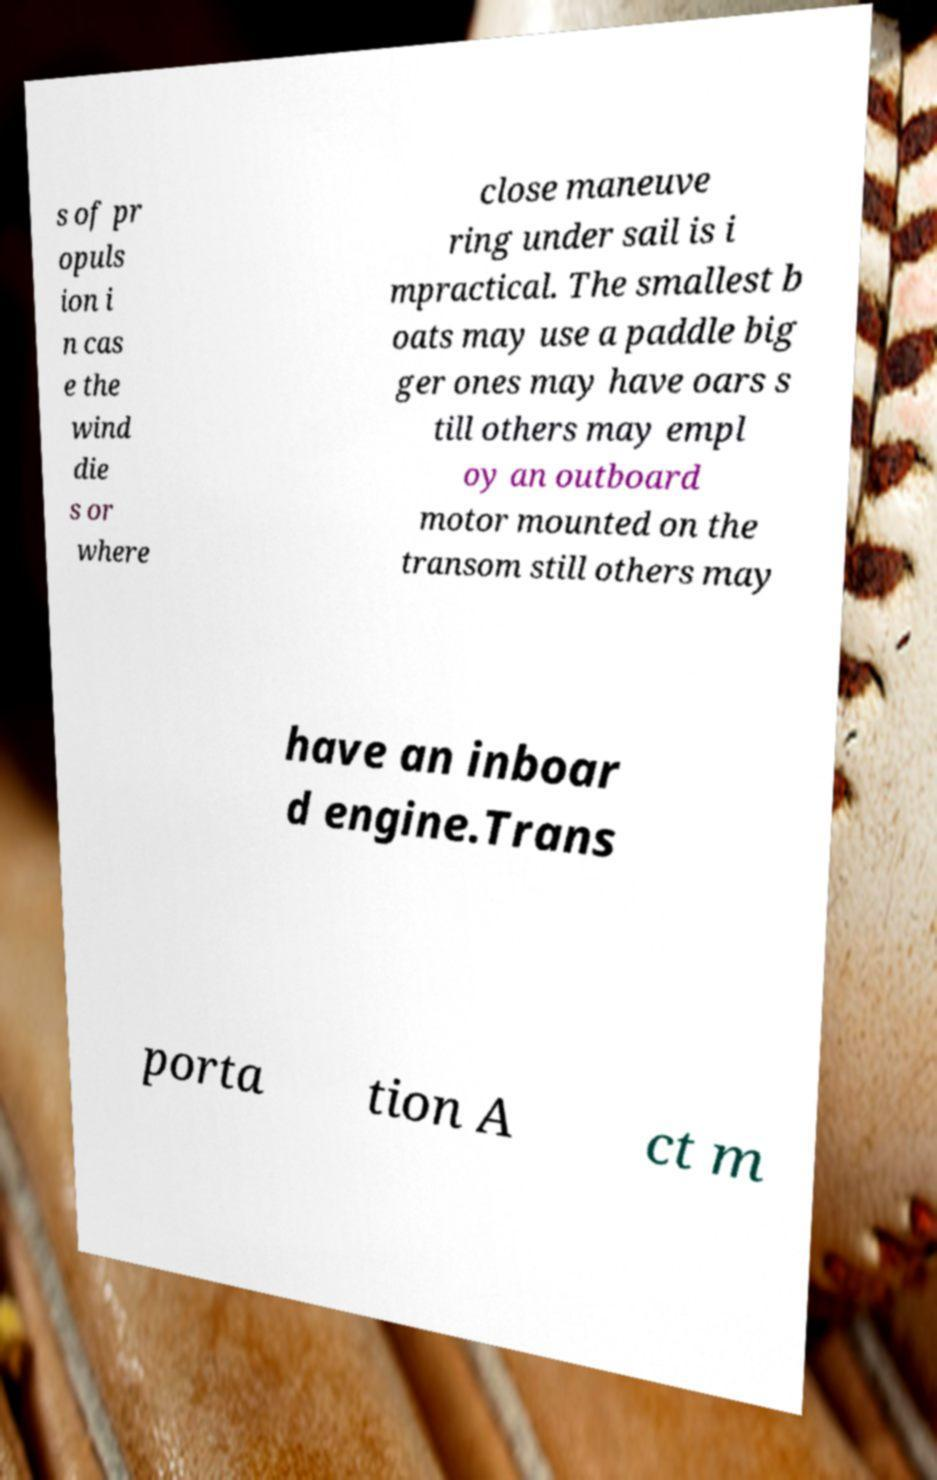There's text embedded in this image that I need extracted. Can you transcribe it verbatim? s of pr opuls ion i n cas e the wind die s or where close maneuve ring under sail is i mpractical. The smallest b oats may use a paddle big ger ones may have oars s till others may empl oy an outboard motor mounted on the transom still others may have an inboar d engine.Trans porta tion A ct m 